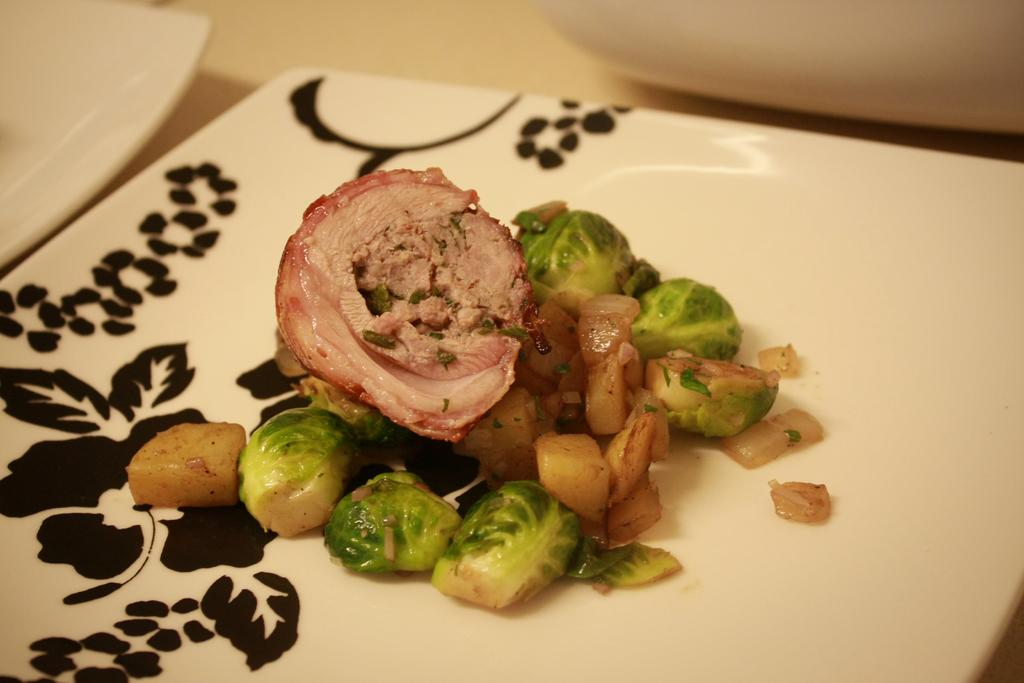What objects can be seen in the image? There are plates in the image. What is on one of the plates? There is a food item on a plate. Where are the plates and food item located? The plates and food item are placed on a platform. What type of doll can be seen in the cave in the image? There is no doll or cave present in the image; it only features plates and a food item on a platform. 